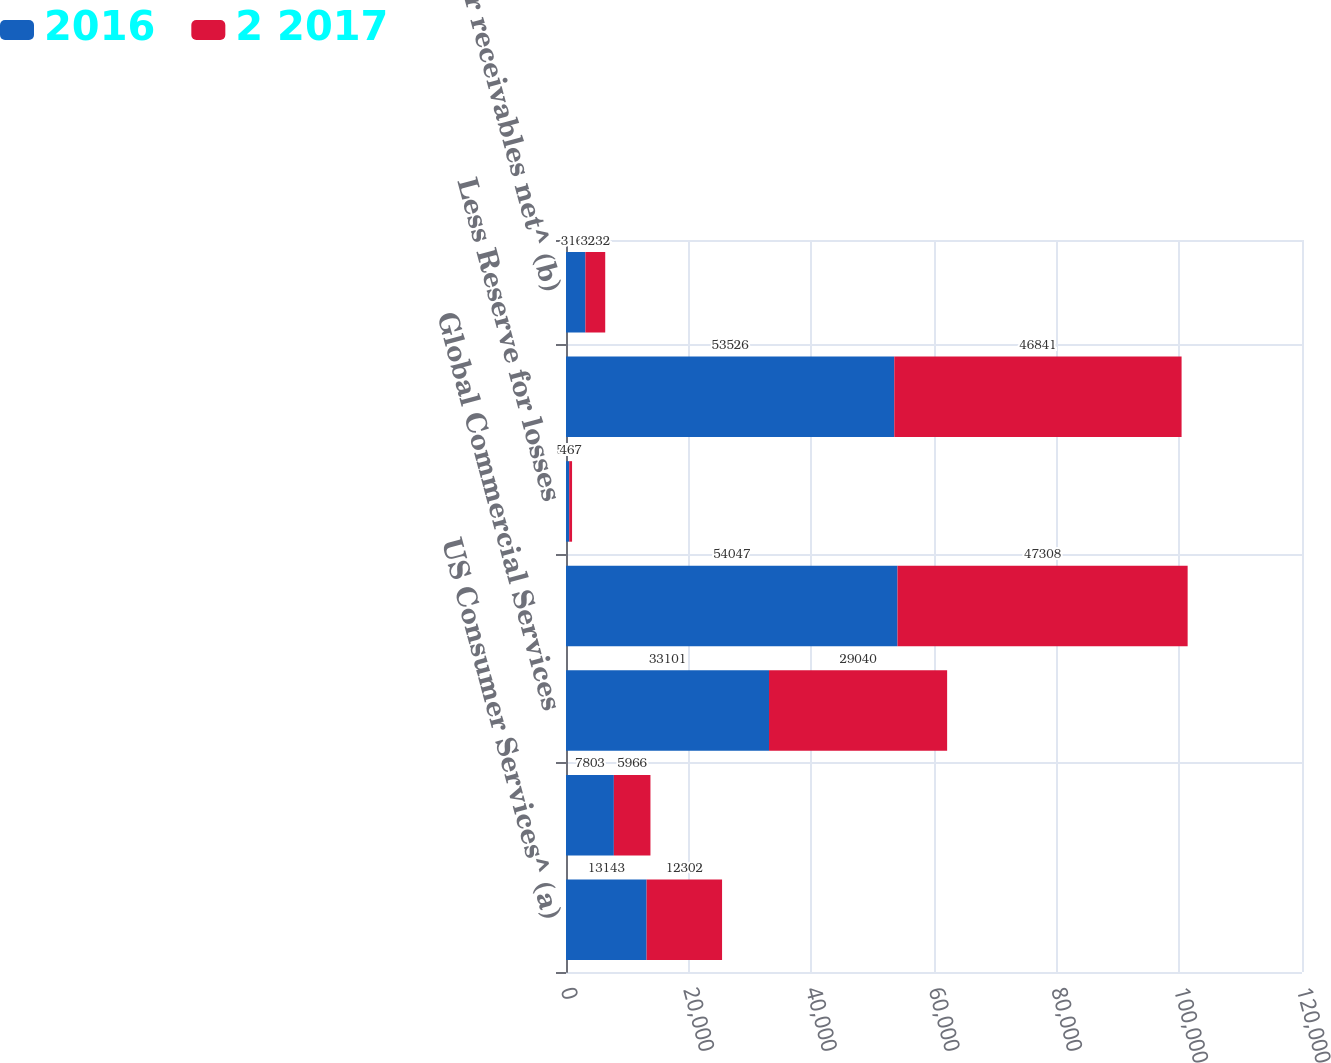<chart> <loc_0><loc_0><loc_500><loc_500><stacked_bar_chart><ecel><fcel>US Consumer Services^ (a)<fcel>International Consumer and<fcel>Global Commercial Services<fcel>Card Member receivables<fcel>Less Reserve for losses<fcel>Card Member receivables net<fcel>Other receivables net^ (b)<nl><fcel>2016<fcel>13143<fcel>7803<fcel>33101<fcel>54047<fcel>521<fcel>53526<fcel>3163<nl><fcel>2 2017<fcel>12302<fcel>5966<fcel>29040<fcel>47308<fcel>467<fcel>46841<fcel>3232<nl></chart> 